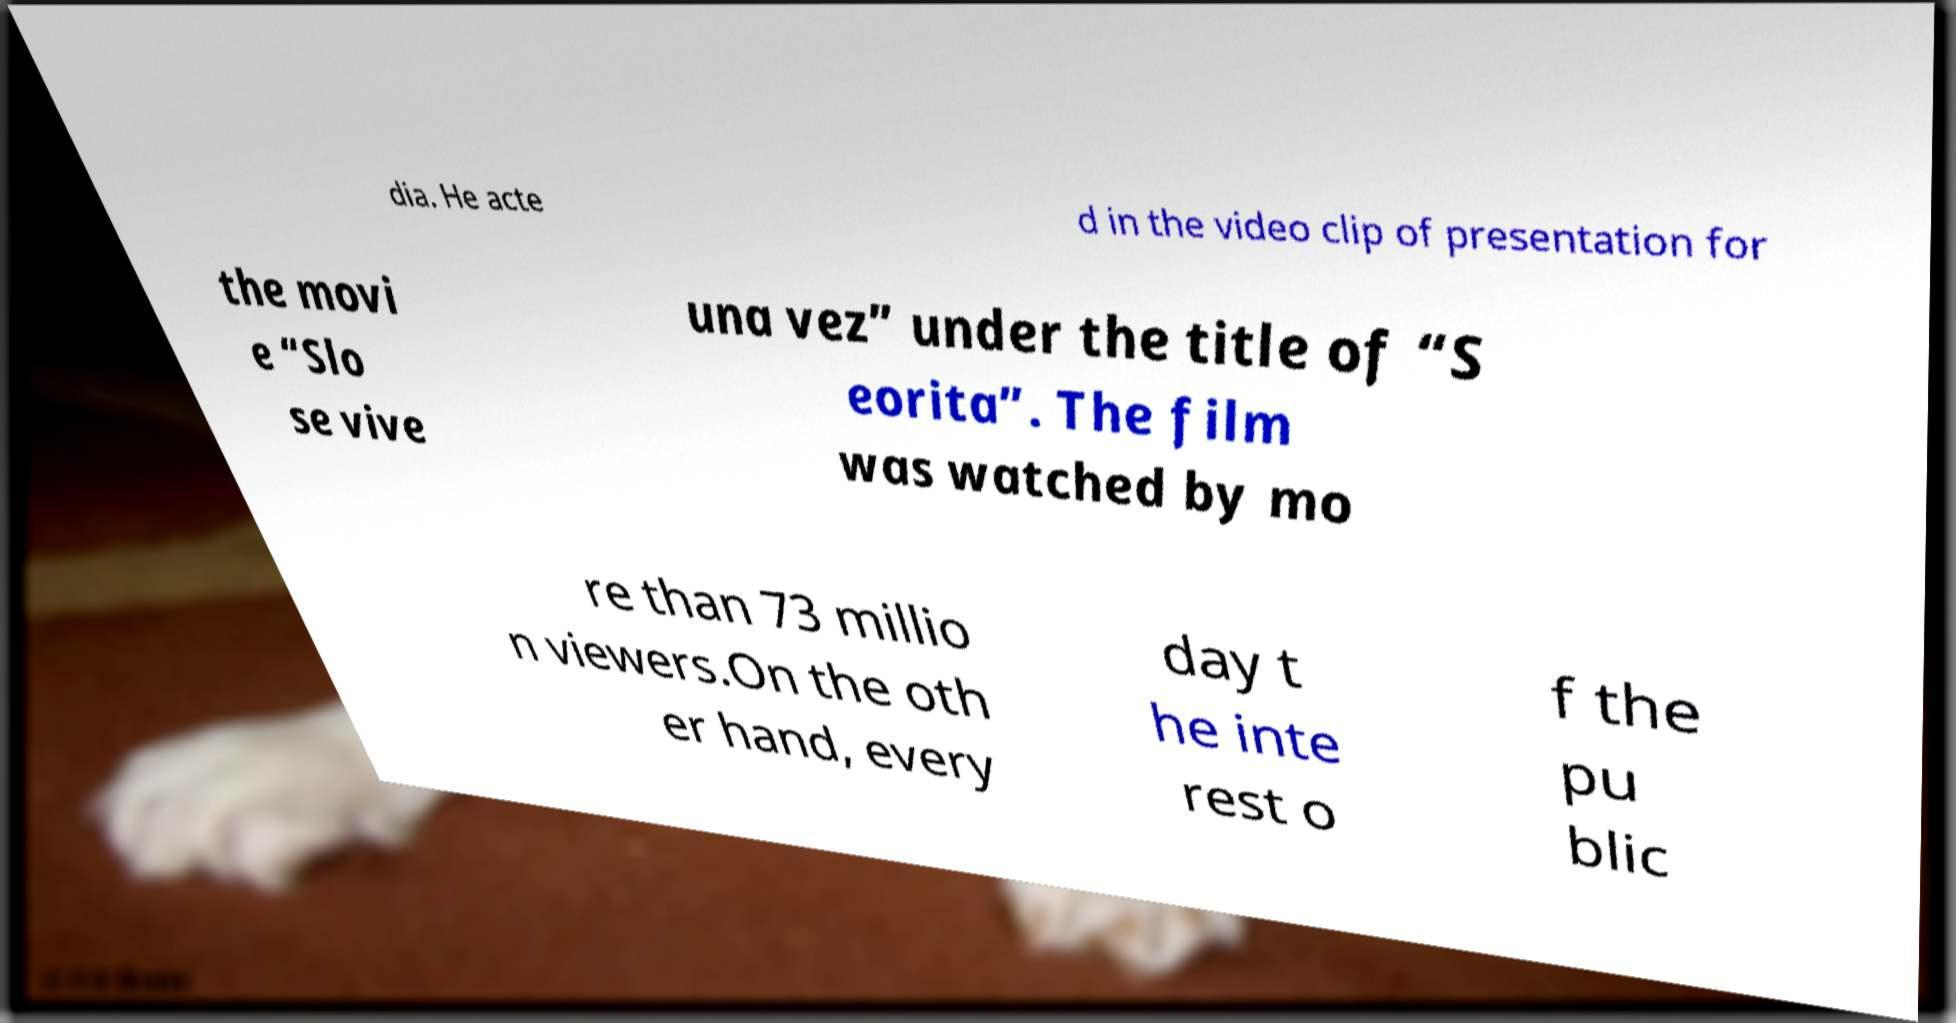Can you accurately transcribe the text from the provided image for me? dia. He acte d in the video clip of presentation for the movi e “Slo se vive una vez” under the title of “S eorita”. The film was watched by mo re than 73 millio n viewers.On the oth er hand, every day t he inte rest o f the pu blic 